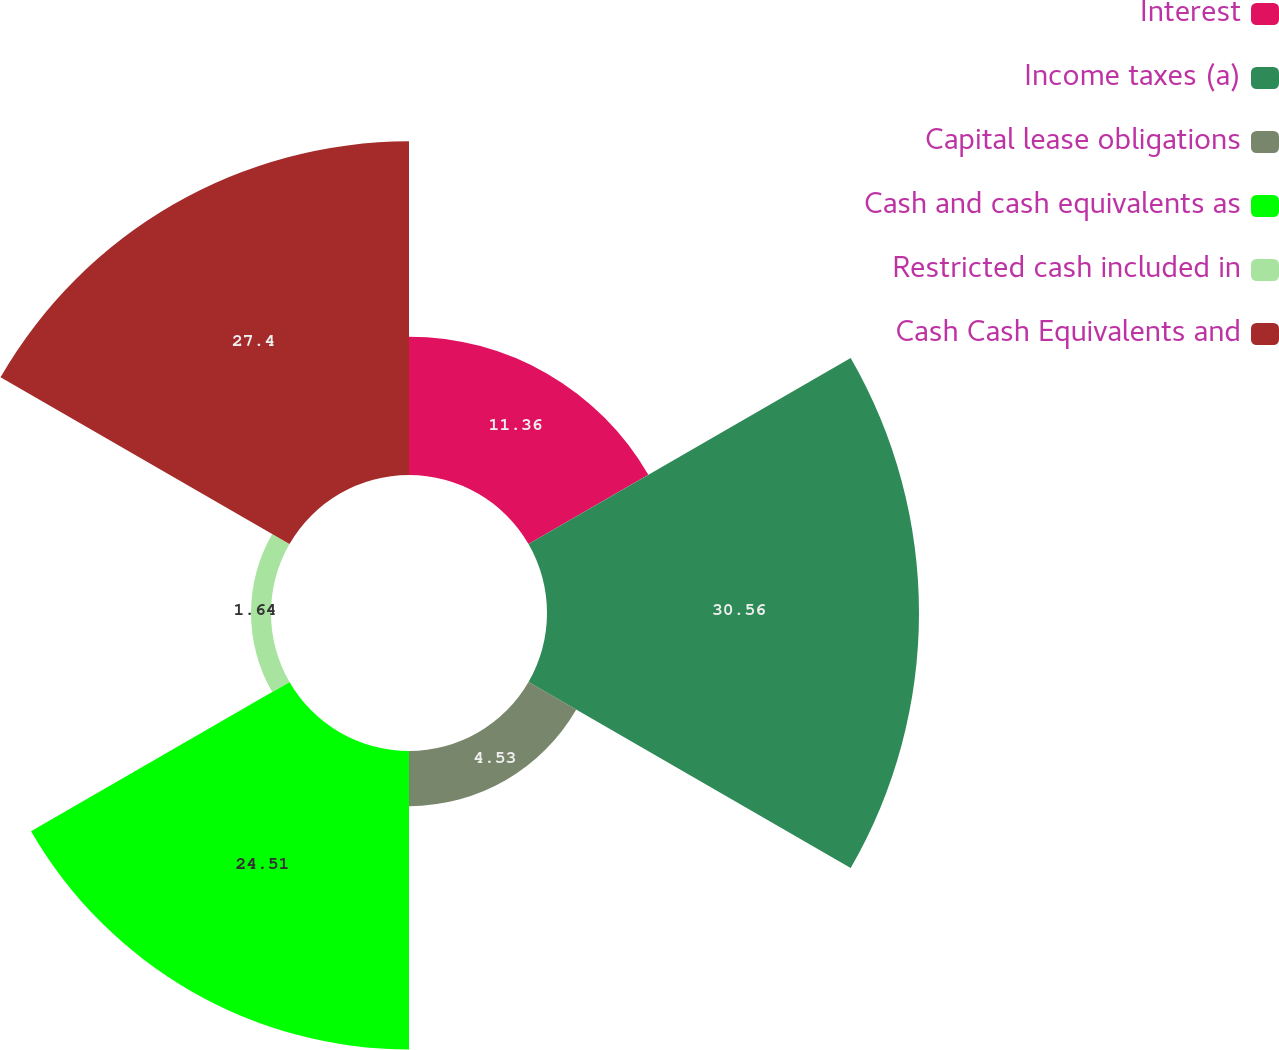<chart> <loc_0><loc_0><loc_500><loc_500><pie_chart><fcel>Interest<fcel>Income taxes (a)<fcel>Capital lease obligations<fcel>Cash and cash equivalents as<fcel>Restricted cash included in<fcel>Cash Cash Equivalents and<nl><fcel>11.36%<fcel>30.55%<fcel>4.53%<fcel>24.51%<fcel>1.64%<fcel>27.4%<nl></chart> 